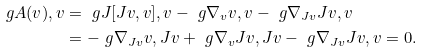Convert formula to latex. <formula><loc_0><loc_0><loc_500><loc_500>\ g { A ( v ) , v } & = \ g { J [ J v , v ] , v } - \ g { \nabla _ { v } v , v } - \ g { \nabla _ { J v } J v , v } \\ & = - \ g { \nabla _ { J v } v , J v } + \ g { \nabla _ { v } J v , J v } - \ g { \nabla _ { J v } J v , v } = 0 .</formula> 